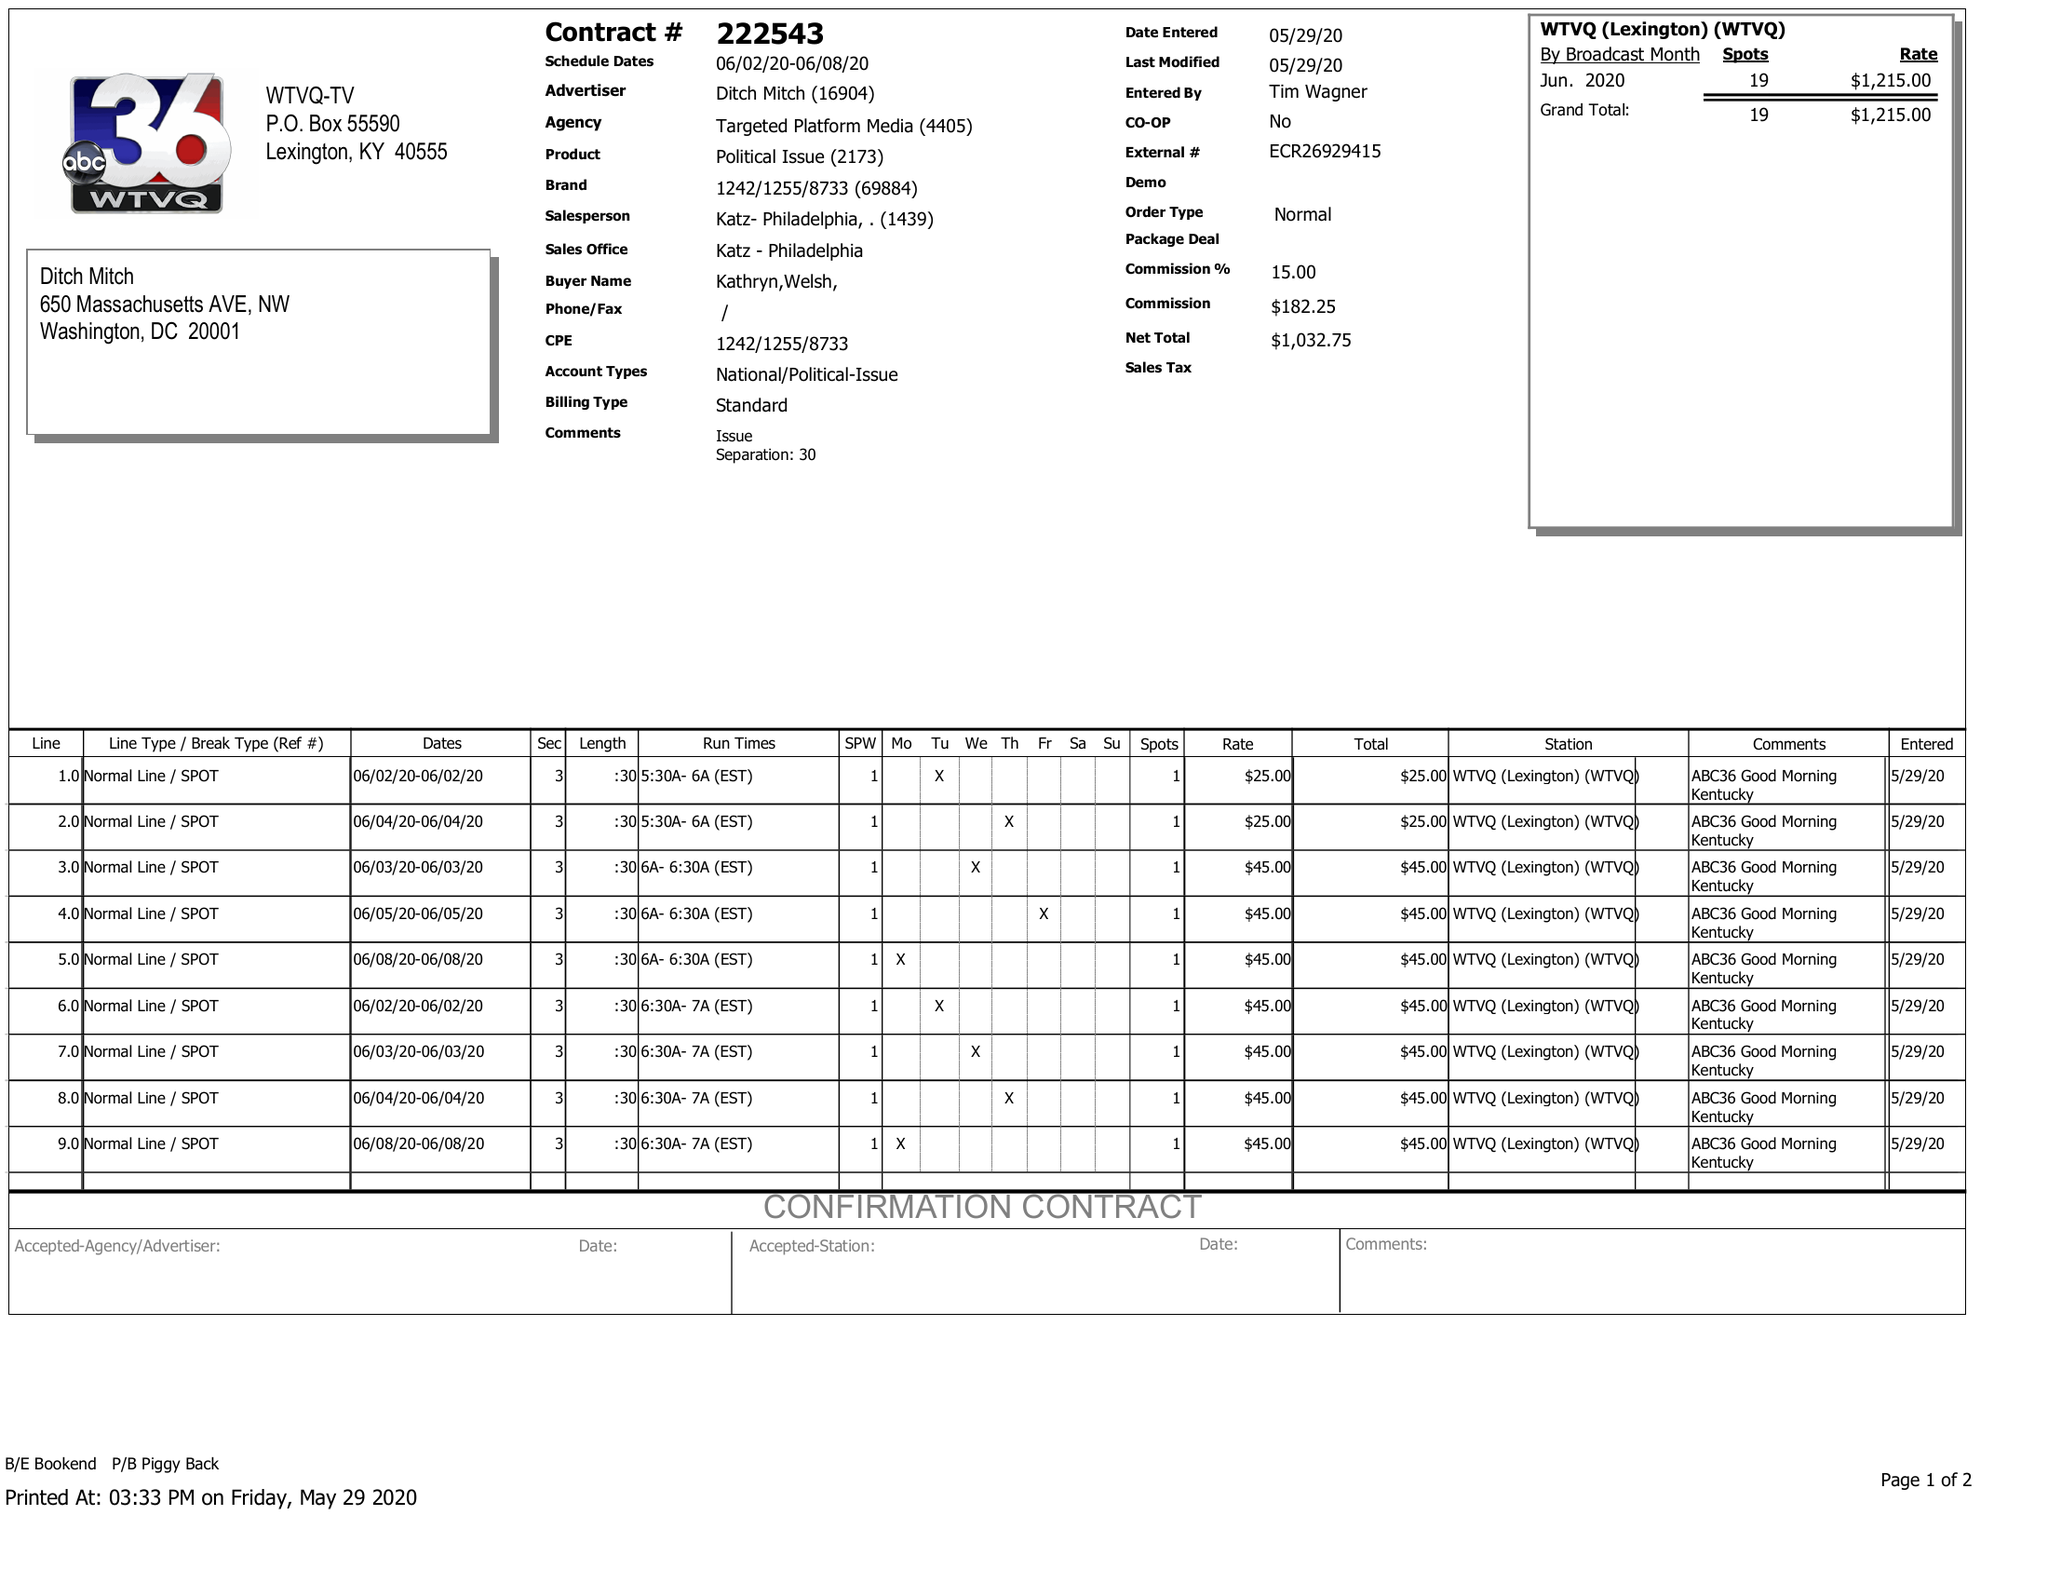What is the value for the contract_num?
Answer the question using a single word or phrase. 222543 